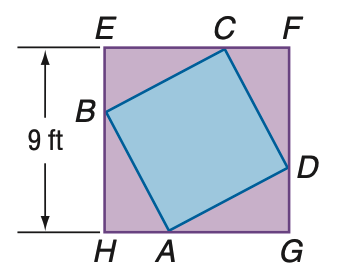Question: In the figure, the vertices of quadrilateral A B C D intersect square E F G H and divide its sides into segments with measure that have a ratio of 1:2. Find the ratio between the areas of A B C D and E F G H.
Choices:
A. 1:4
B. 1:2
C. 5:9
D. 1: \sqrt 2
Answer with the letter. Answer: C Question: In the figure, the vertices of quadrilateral A B C D intersect square E F G H and divide its sides into segments with measure that have a ratio of 1:2. Find the area of A B C D.
Choices:
A. 40.5
B. 45
C. 63
D. 81
Answer with the letter. Answer: B 